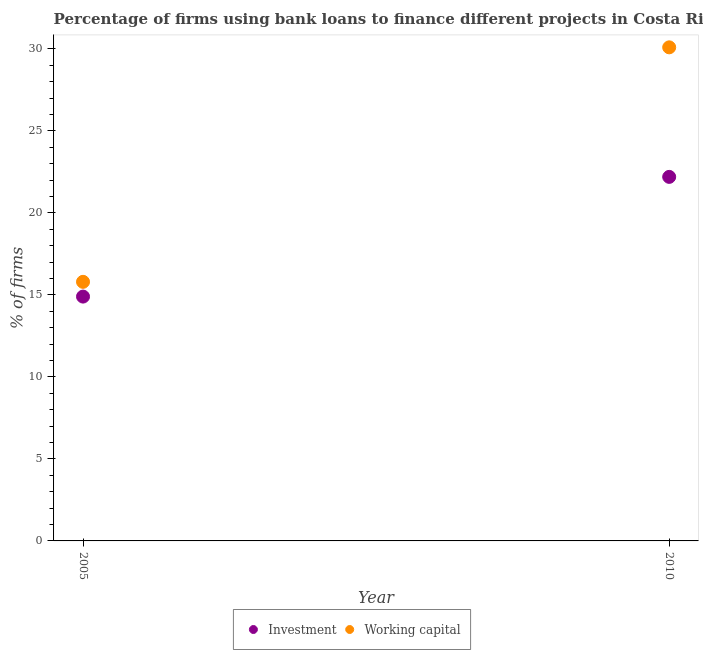Across all years, what is the minimum percentage of firms using banks to finance investment?
Offer a terse response. 14.9. What is the total percentage of firms using banks to finance working capital in the graph?
Make the answer very short. 45.9. What is the difference between the percentage of firms using banks to finance investment in 2005 and that in 2010?
Offer a very short reply. -7.3. What is the difference between the percentage of firms using banks to finance investment in 2010 and the percentage of firms using banks to finance working capital in 2005?
Keep it short and to the point. 6.4. What is the average percentage of firms using banks to finance investment per year?
Your answer should be compact. 18.55. In the year 2010, what is the difference between the percentage of firms using banks to finance working capital and percentage of firms using banks to finance investment?
Offer a terse response. 7.9. In how many years, is the percentage of firms using banks to finance working capital greater than 21 %?
Provide a short and direct response. 1. What is the ratio of the percentage of firms using banks to finance investment in 2005 to that in 2010?
Give a very brief answer. 0.67. Is the percentage of firms using banks to finance investment in 2005 less than that in 2010?
Provide a succinct answer. Yes. In how many years, is the percentage of firms using banks to finance investment greater than the average percentage of firms using banks to finance investment taken over all years?
Your response must be concise. 1. Does the percentage of firms using banks to finance investment monotonically increase over the years?
Make the answer very short. Yes. Is the percentage of firms using banks to finance investment strictly greater than the percentage of firms using banks to finance working capital over the years?
Provide a short and direct response. No. What is the difference between two consecutive major ticks on the Y-axis?
Give a very brief answer. 5. Are the values on the major ticks of Y-axis written in scientific E-notation?
Provide a short and direct response. No. Does the graph contain any zero values?
Your answer should be compact. No. Does the graph contain grids?
Make the answer very short. No. How many legend labels are there?
Offer a very short reply. 2. What is the title of the graph?
Ensure brevity in your answer.  Percentage of firms using bank loans to finance different projects in Costa Rica. What is the label or title of the X-axis?
Your answer should be very brief. Year. What is the label or title of the Y-axis?
Ensure brevity in your answer.  % of firms. What is the % of firms in Investment in 2005?
Provide a short and direct response. 14.9. What is the % of firms in Working capital in 2005?
Make the answer very short. 15.8. What is the % of firms of Working capital in 2010?
Keep it short and to the point. 30.1. Across all years, what is the maximum % of firms in Investment?
Your response must be concise. 22.2. Across all years, what is the maximum % of firms in Working capital?
Your response must be concise. 30.1. What is the total % of firms in Investment in the graph?
Your answer should be very brief. 37.1. What is the total % of firms of Working capital in the graph?
Provide a succinct answer. 45.9. What is the difference between the % of firms in Investment in 2005 and that in 2010?
Your response must be concise. -7.3. What is the difference between the % of firms in Working capital in 2005 and that in 2010?
Make the answer very short. -14.3. What is the difference between the % of firms in Investment in 2005 and the % of firms in Working capital in 2010?
Your response must be concise. -15.2. What is the average % of firms in Investment per year?
Give a very brief answer. 18.55. What is the average % of firms of Working capital per year?
Offer a terse response. 22.95. In the year 2005, what is the difference between the % of firms of Investment and % of firms of Working capital?
Make the answer very short. -0.9. What is the ratio of the % of firms of Investment in 2005 to that in 2010?
Make the answer very short. 0.67. What is the ratio of the % of firms of Working capital in 2005 to that in 2010?
Your response must be concise. 0.52. What is the difference between the highest and the second highest % of firms in Investment?
Ensure brevity in your answer.  7.3. 